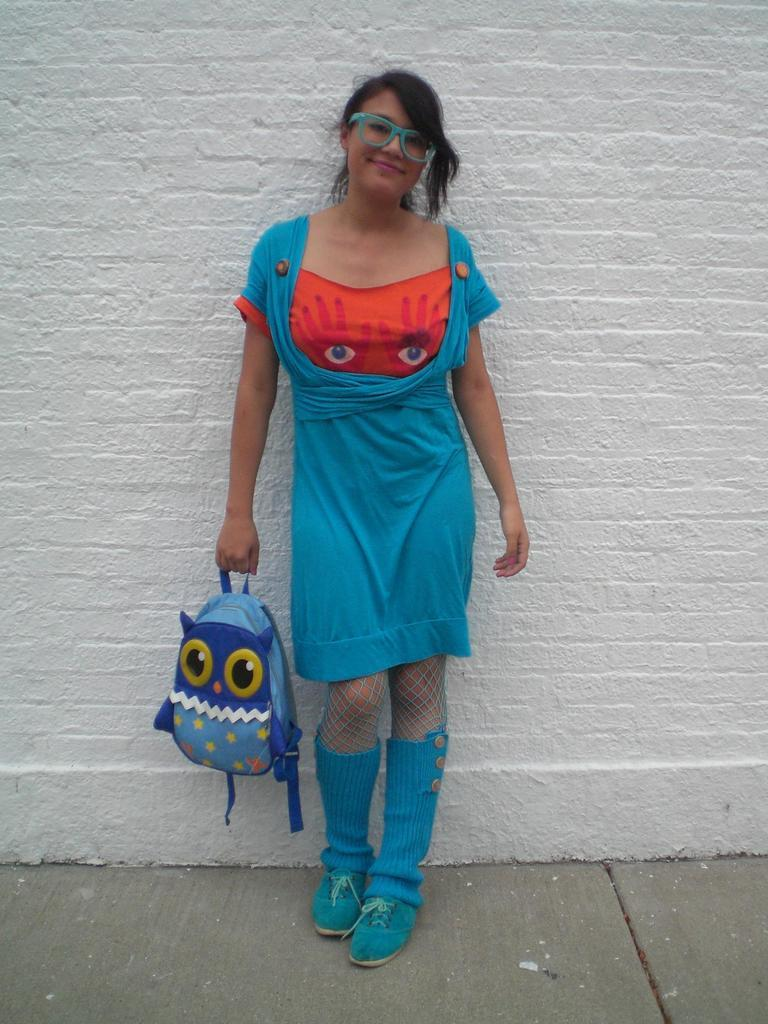What is the main subject of the image? The main subject of the image is a woman. What is the woman doing in the image? The woman is standing in the image. Can you describe the woman's appearance? The woman is wearing spectacles and is smiling. What is the woman holding in her hand? The woman is holding a bag in her hand. What type of stew is the woman eating in the image? There is no stew present in the image; the woman is not eating anything. What can be seen from the woman's nose in the image? The woman's nose is not a focus in the image, and there is no specific view mentioned. 